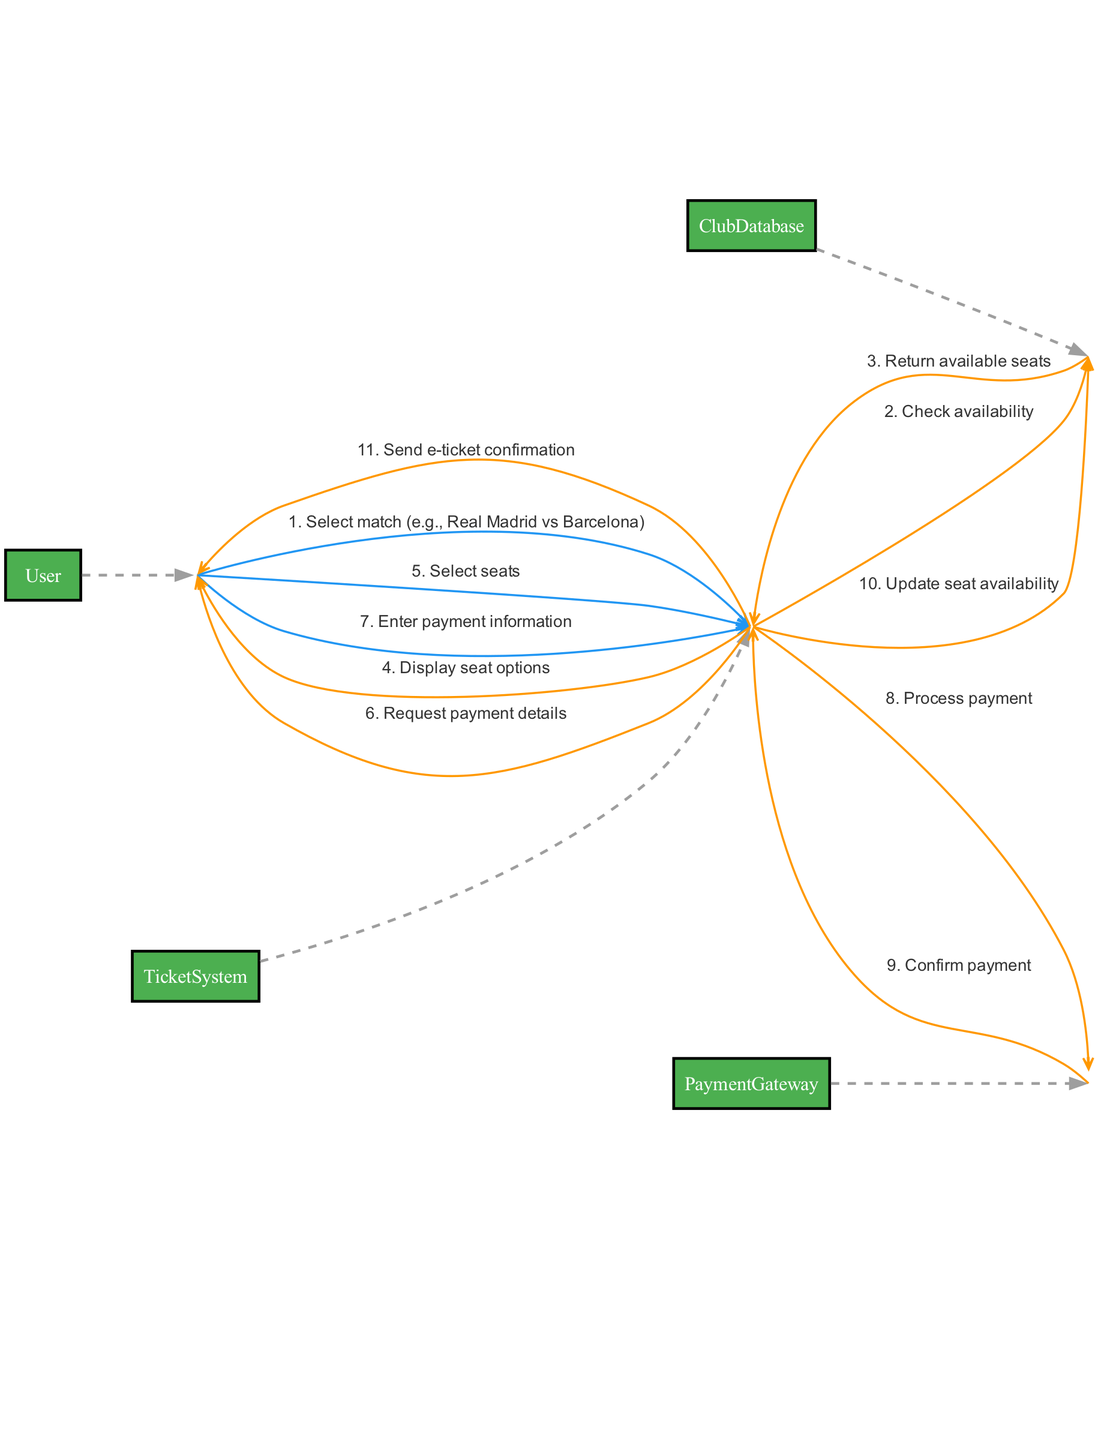What are the actors involved in the booking flow? The actors listed in the diagram include User, TicketSystem, PaymentGateway, and ClubDatabase. These actors represent the participants in the ticket booking process.
Answer: User, TicketSystem, PaymentGateway, ClubDatabase How many interactions are present in the diagram? By counting each line representing an interaction, we can see there are 11 interactions outlined in the diagram. These interactions detail the communication between actors.
Answer: 11 What is the first action taken by the User? The diagram shows that the first action taken by the User is "Select match (e.g., Real Madrid vs Barcelona)". This indicates the initiation of the booking process.
Answer: Select match Which actor checks availability of seats? The TicketSystem is responsible for checking the availability of seats by communicating with the ClubDatabase. This process occurs immediately after the User selects a match.
Answer: TicketSystem What is the last step in the ticket booking process? The last step is that the TicketSystem sends an e-ticket confirmation to the User, which concludes the booking flow by providing the User with the necessary confirmation.
Answer: Send e-ticket confirmation What does the PaymentGateway do after processing the payment? The PaymentGateway sends a payment confirmation back to the TicketSystem after processing the payment. This step ensures that the TicketSystem is informed about the successful transaction.
Answer: Confirm payment Which actor updates seat availability? The TicketSystem updates the seat availability after confirming the payment with the PaymentGateway, ensuring that the booked seats are no longer available for other users.
Answer: TicketSystem How many messages does the TicketSystem send to the User? The TicketSystem sends three messages to the User: displaying seat options, requesting payment details, and sending e-ticket confirmation. This includes steps necessary for the User's interaction during the booking process.
Answer: 3 